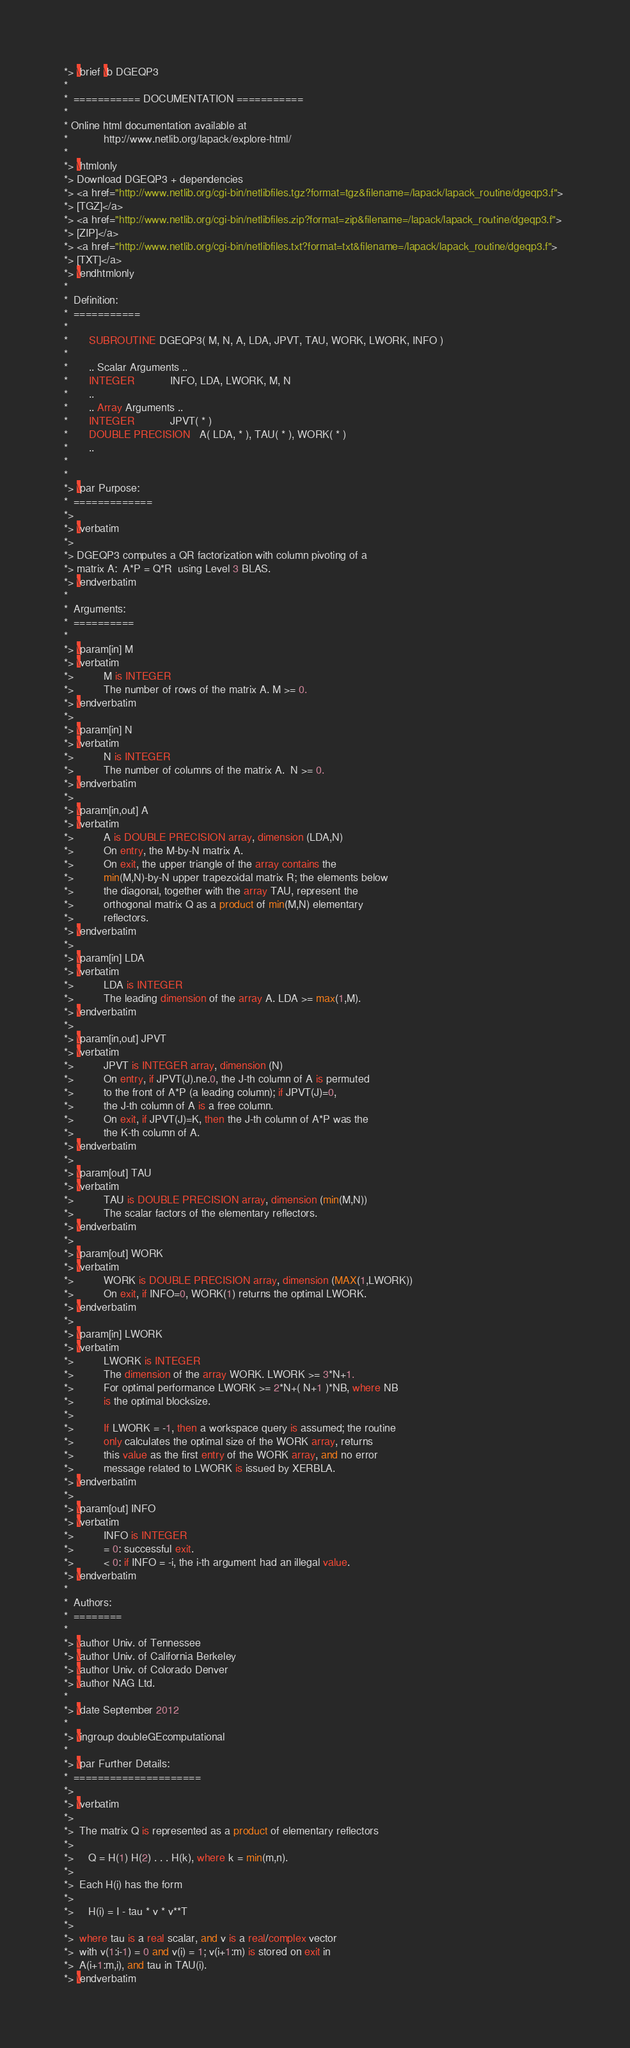<code> <loc_0><loc_0><loc_500><loc_500><_FORTRAN_>*> \brief \b DGEQP3
*
*  =========== DOCUMENTATION ===========
*
* Online html documentation available at 
*            http://www.netlib.org/lapack/explore-html/ 
*
*> \htmlonly
*> Download DGEQP3 + dependencies 
*> <a href="http://www.netlib.org/cgi-bin/netlibfiles.tgz?format=tgz&filename=/lapack/lapack_routine/dgeqp3.f"> 
*> [TGZ]</a> 
*> <a href="http://www.netlib.org/cgi-bin/netlibfiles.zip?format=zip&filename=/lapack/lapack_routine/dgeqp3.f"> 
*> [ZIP]</a> 
*> <a href="http://www.netlib.org/cgi-bin/netlibfiles.txt?format=txt&filename=/lapack/lapack_routine/dgeqp3.f"> 
*> [TXT]</a>
*> \endhtmlonly 
*
*  Definition:
*  ===========
*
*       SUBROUTINE DGEQP3( M, N, A, LDA, JPVT, TAU, WORK, LWORK, INFO )
* 
*       .. Scalar Arguments ..
*       INTEGER            INFO, LDA, LWORK, M, N
*       ..
*       .. Array Arguments ..
*       INTEGER            JPVT( * )
*       DOUBLE PRECISION   A( LDA, * ), TAU( * ), WORK( * )
*       ..
*  
*
*> \par Purpose:
*  =============
*>
*> \verbatim
*>
*> DGEQP3 computes a QR factorization with column pivoting of a
*> matrix A:  A*P = Q*R  using Level 3 BLAS.
*> \endverbatim
*
*  Arguments:
*  ==========
*
*> \param[in] M
*> \verbatim
*>          M is INTEGER
*>          The number of rows of the matrix A. M >= 0.
*> \endverbatim
*>
*> \param[in] N
*> \verbatim
*>          N is INTEGER
*>          The number of columns of the matrix A.  N >= 0.
*> \endverbatim
*>
*> \param[in,out] A
*> \verbatim
*>          A is DOUBLE PRECISION array, dimension (LDA,N)
*>          On entry, the M-by-N matrix A.
*>          On exit, the upper triangle of the array contains the
*>          min(M,N)-by-N upper trapezoidal matrix R; the elements below
*>          the diagonal, together with the array TAU, represent the
*>          orthogonal matrix Q as a product of min(M,N) elementary
*>          reflectors.
*> \endverbatim
*>
*> \param[in] LDA
*> \verbatim
*>          LDA is INTEGER
*>          The leading dimension of the array A. LDA >= max(1,M).
*> \endverbatim
*>
*> \param[in,out] JPVT
*> \verbatim
*>          JPVT is INTEGER array, dimension (N)
*>          On entry, if JPVT(J).ne.0, the J-th column of A is permuted
*>          to the front of A*P (a leading column); if JPVT(J)=0,
*>          the J-th column of A is a free column.
*>          On exit, if JPVT(J)=K, then the J-th column of A*P was the
*>          the K-th column of A.
*> \endverbatim
*>
*> \param[out] TAU
*> \verbatim
*>          TAU is DOUBLE PRECISION array, dimension (min(M,N))
*>          The scalar factors of the elementary reflectors.
*> \endverbatim
*>
*> \param[out] WORK
*> \verbatim
*>          WORK is DOUBLE PRECISION array, dimension (MAX(1,LWORK))
*>          On exit, if INFO=0, WORK(1) returns the optimal LWORK.
*> \endverbatim
*>
*> \param[in] LWORK
*> \verbatim
*>          LWORK is INTEGER
*>          The dimension of the array WORK. LWORK >= 3*N+1.
*>          For optimal performance LWORK >= 2*N+( N+1 )*NB, where NB
*>          is the optimal blocksize.
*>
*>          If LWORK = -1, then a workspace query is assumed; the routine
*>          only calculates the optimal size of the WORK array, returns
*>          this value as the first entry of the WORK array, and no error
*>          message related to LWORK is issued by XERBLA.
*> \endverbatim
*>
*> \param[out] INFO
*> \verbatim
*>          INFO is INTEGER
*>          = 0: successful exit.
*>          < 0: if INFO = -i, the i-th argument had an illegal value.
*> \endverbatim
*
*  Authors:
*  ========
*
*> \author Univ. of Tennessee 
*> \author Univ. of California Berkeley 
*> \author Univ. of Colorado Denver 
*> \author NAG Ltd. 
*
*> \date September 2012
*
*> \ingroup doubleGEcomputational
*
*> \par Further Details:
*  =====================
*>
*> \verbatim
*>
*>  The matrix Q is represented as a product of elementary reflectors
*>
*>     Q = H(1) H(2) . . . H(k), where k = min(m,n).
*>
*>  Each H(i) has the form
*>
*>     H(i) = I - tau * v * v**T
*>
*>  where tau is a real scalar, and v is a real/complex vector
*>  with v(1:i-1) = 0 and v(i) = 1; v(i+1:m) is stored on exit in
*>  A(i+1:m,i), and tau in TAU(i).
*> \endverbatim</code> 